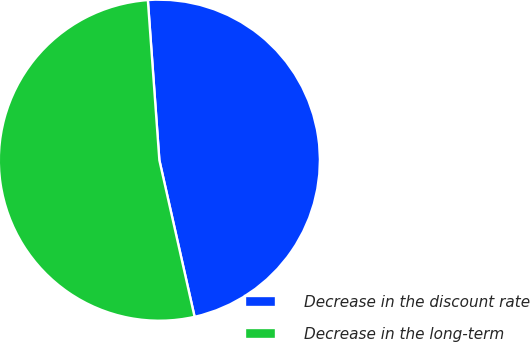Convert chart. <chart><loc_0><loc_0><loc_500><loc_500><pie_chart><fcel>Decrease in the discount rate<fcel>Decrease in the long-term<nl><fcel>47.62%<fcel>52.38%<nl></chart> 